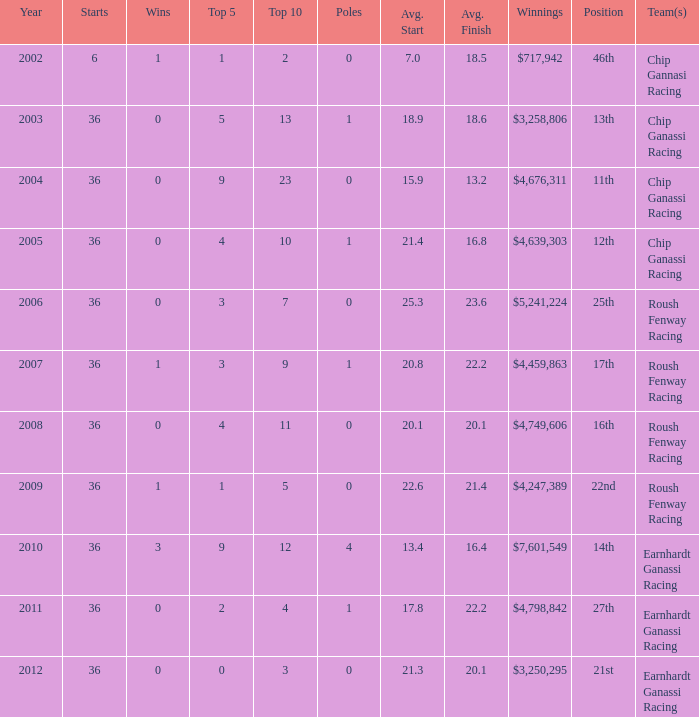Name the poles for 25th position 0.0. 